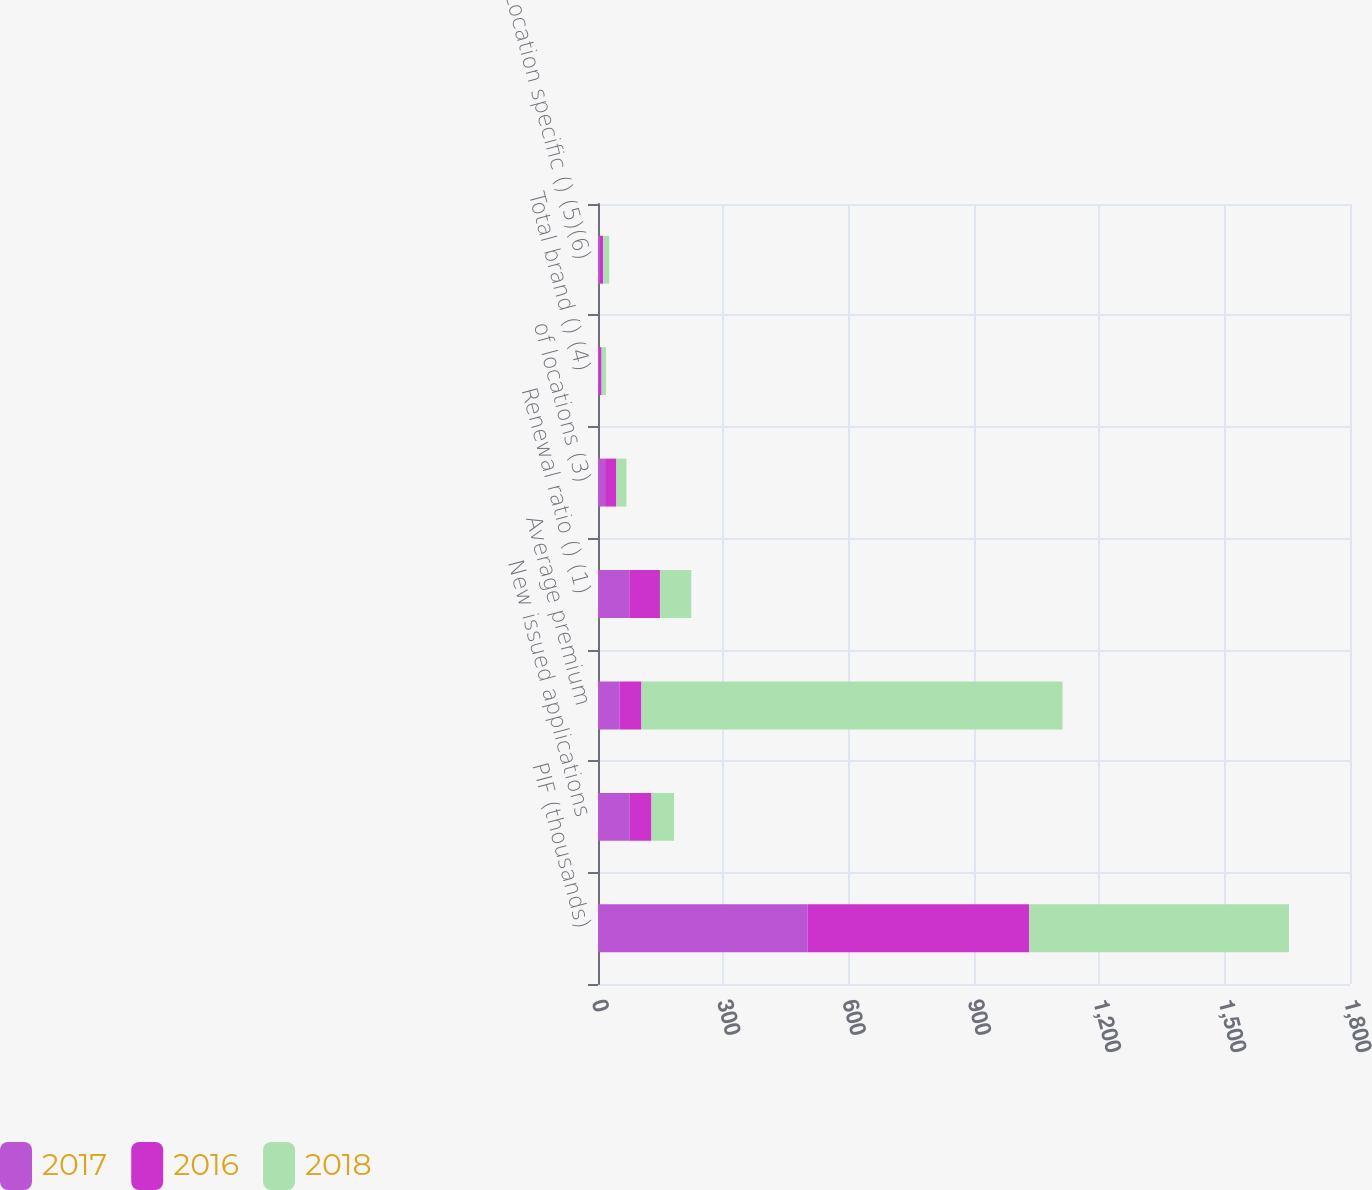<chart> <loc_0><loc_0><loc_500><loc_500><stacked_bar_chart><ecel><fcel>PIF (thousands)<fcel>New issued applications<fcel>Average premium<fcel>Renewal ratio () (1)<fcel>of locations (3)<fcel>Total brand () (4)<fcel>Location specific () (5)(6)<nl><fcel>2017<fcel>502<fcel>76<fcel>52<fcel>74.9<fcel>17<fcel>2.4<fcel>4.8<nl><fcel>2016<fcel>530<fcel>52<fcel>52<fcel>73.4<fcel>27<fcel>6.2<fcel>7.8<nl><fcel>2018<fcel>622<fcel>54<fcel>1008<fcel>75<fcel>24<fcel>10.5<fcel>14.3<nl></chart> 